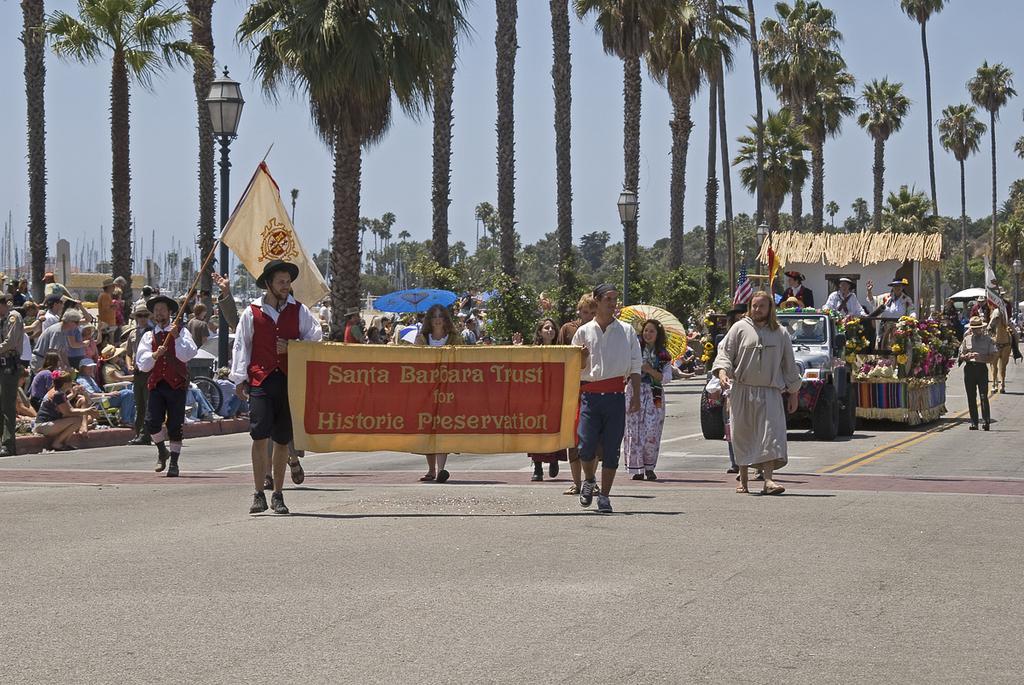Can you describe this image briefly? In this image we can see people, road, flags, umbrellas, banner, vehicle, flowers, poles, lights, horse, and trees. In the background there is sky. 